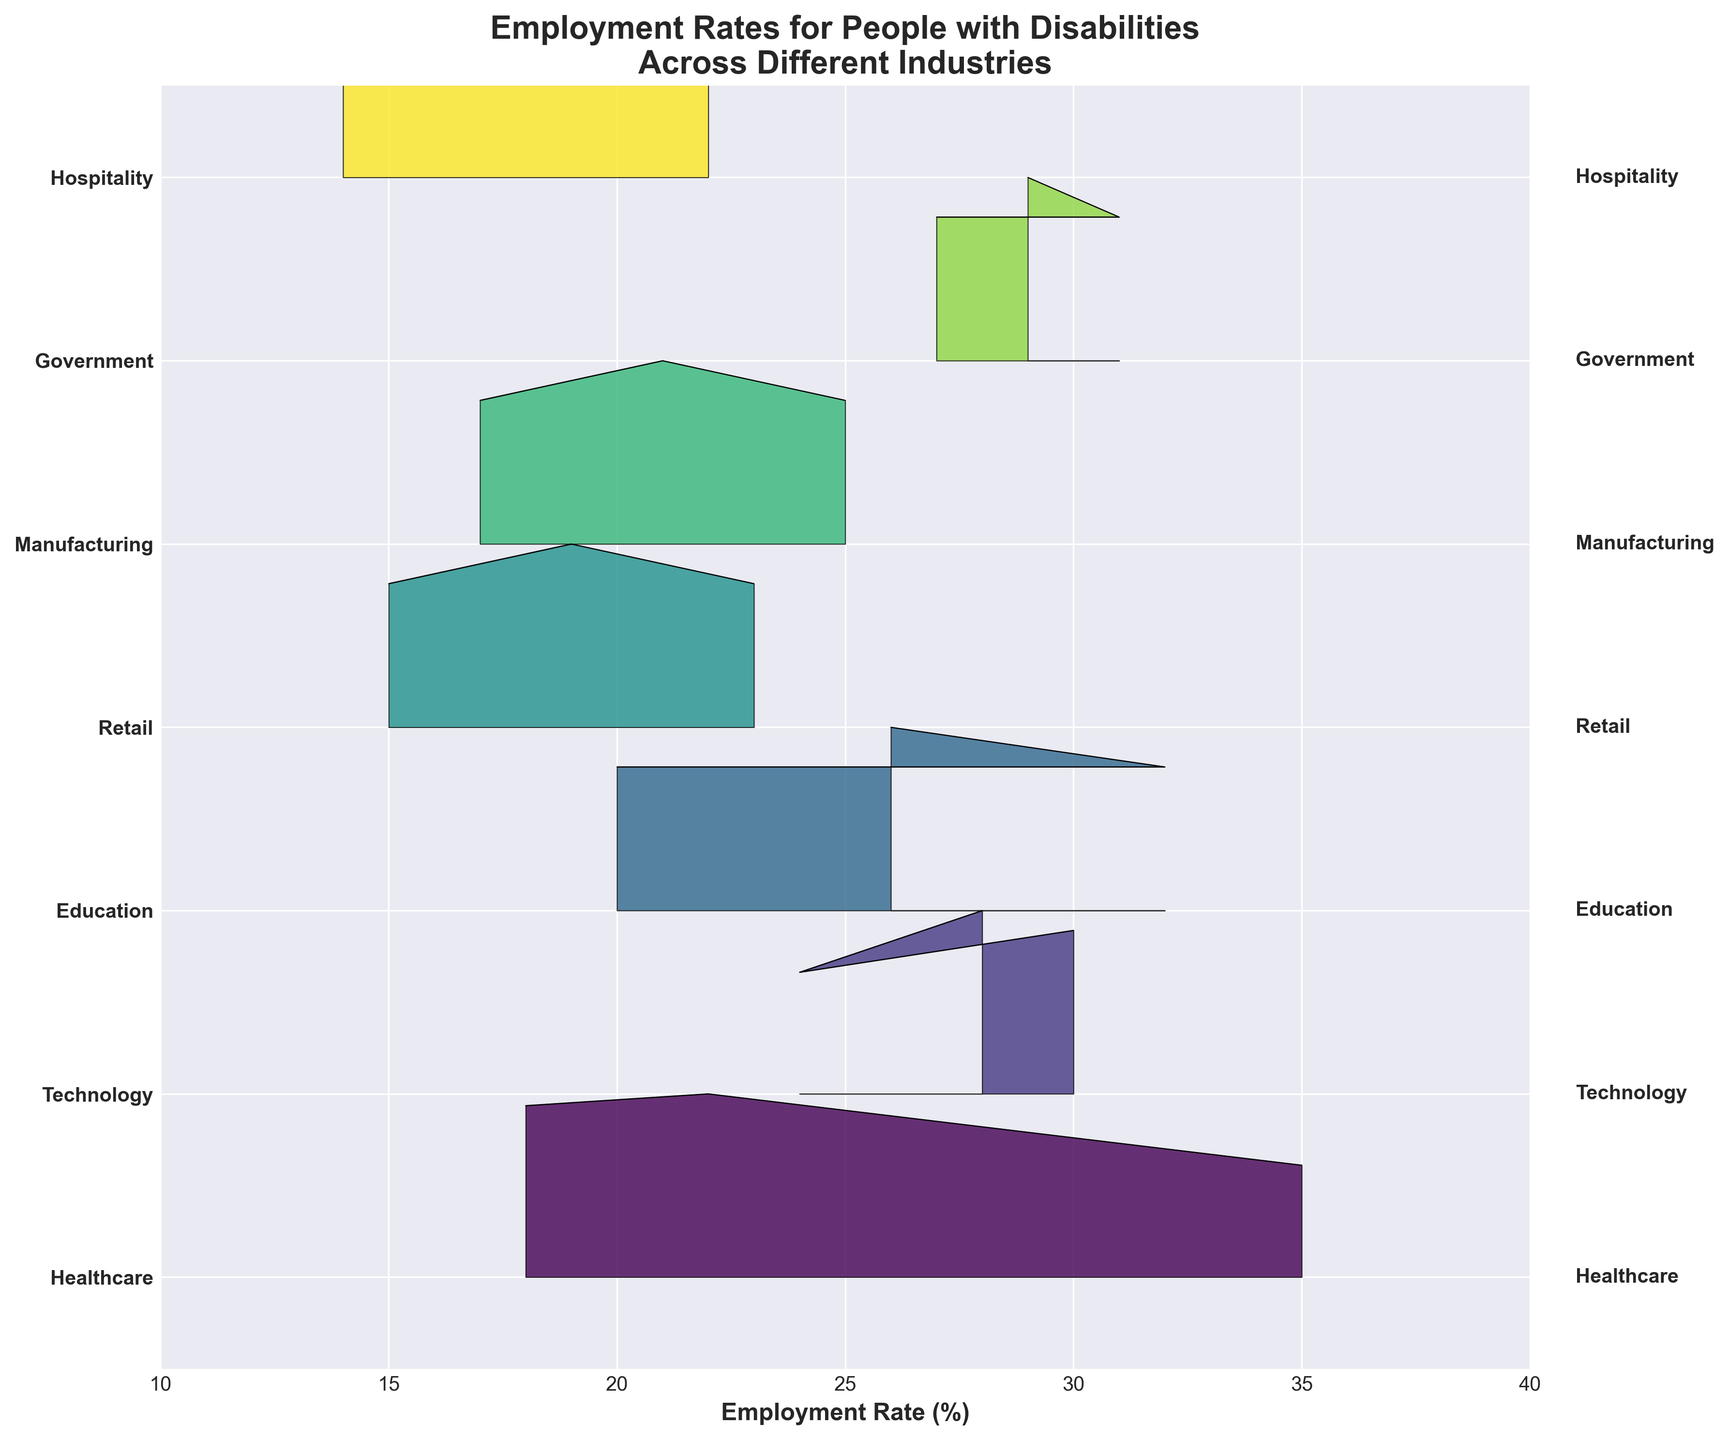What is the title of the ridgeline plot? The title is usually located at the top of the plot. It gives a summary of what the plot is about. In this case, it is "Employment Rates for People with Disabilities Across Different Industries".
Answer: Employment Rates for People with Disabilities Across Different Industries What is the range of the x-axis in the plot? The x-axis shows the employment rates and its range represents the minimum and maximum employment rates shown. According to the setup, it ranges from 10% to 40%.
Answer: 10% to 40% Which industry has the highest employment rate density peak? To determine this, we need to look at the ridgeline plot and identify which industry curve is tallest, which indicates the highest density peak.
Answer: Technology How many industries are represented in the plot? The industries are listed on the y-axis. We can count the number of unique industries displayed.
Answer: Six Which industry has the lowest employment rates? This can be determined by identifying the industry curve whose peaks are located towards the lower end of the x-axis (10%-20%).
Answer: Hospitality What is the employment rate range for the Healthcare industry? The density for Healthcare covers certain employment rates on the x-axis. From the data and the plot, Healthcare rates fall between 18% to 35%.
Answer: 18% to 35% Compare the employment rates for Technology and Education. Which one has higher rates on average? Look at the density peaks and ranges for both Technology and Education. Technology rates lie between 24% to 30%, whereas Education is between 20% to 32%. Technology has a marginally higher density peak but Education has higher maximum values. On average, they may be similar.
Answer: Education slightly Among all industries, which one has the most evenly spread employment rates? This can be determined by observing which industry's density curve covers a wide range uniformly, without sharp peaks.
Answer: Government Which industry shows the largest variance in employment rates? The largest variance would be indicated by the industry whose density curve spans the widest range on the x-axis.
Answer: Healthcare What can you infer about the employment rates in the Retail industry based on the plot? The density curve for Retail industries shows peaks between the range of 15% to 23%, which suggests that most employment rates are on the lower side compared to other industries.
Answer: Lower side 